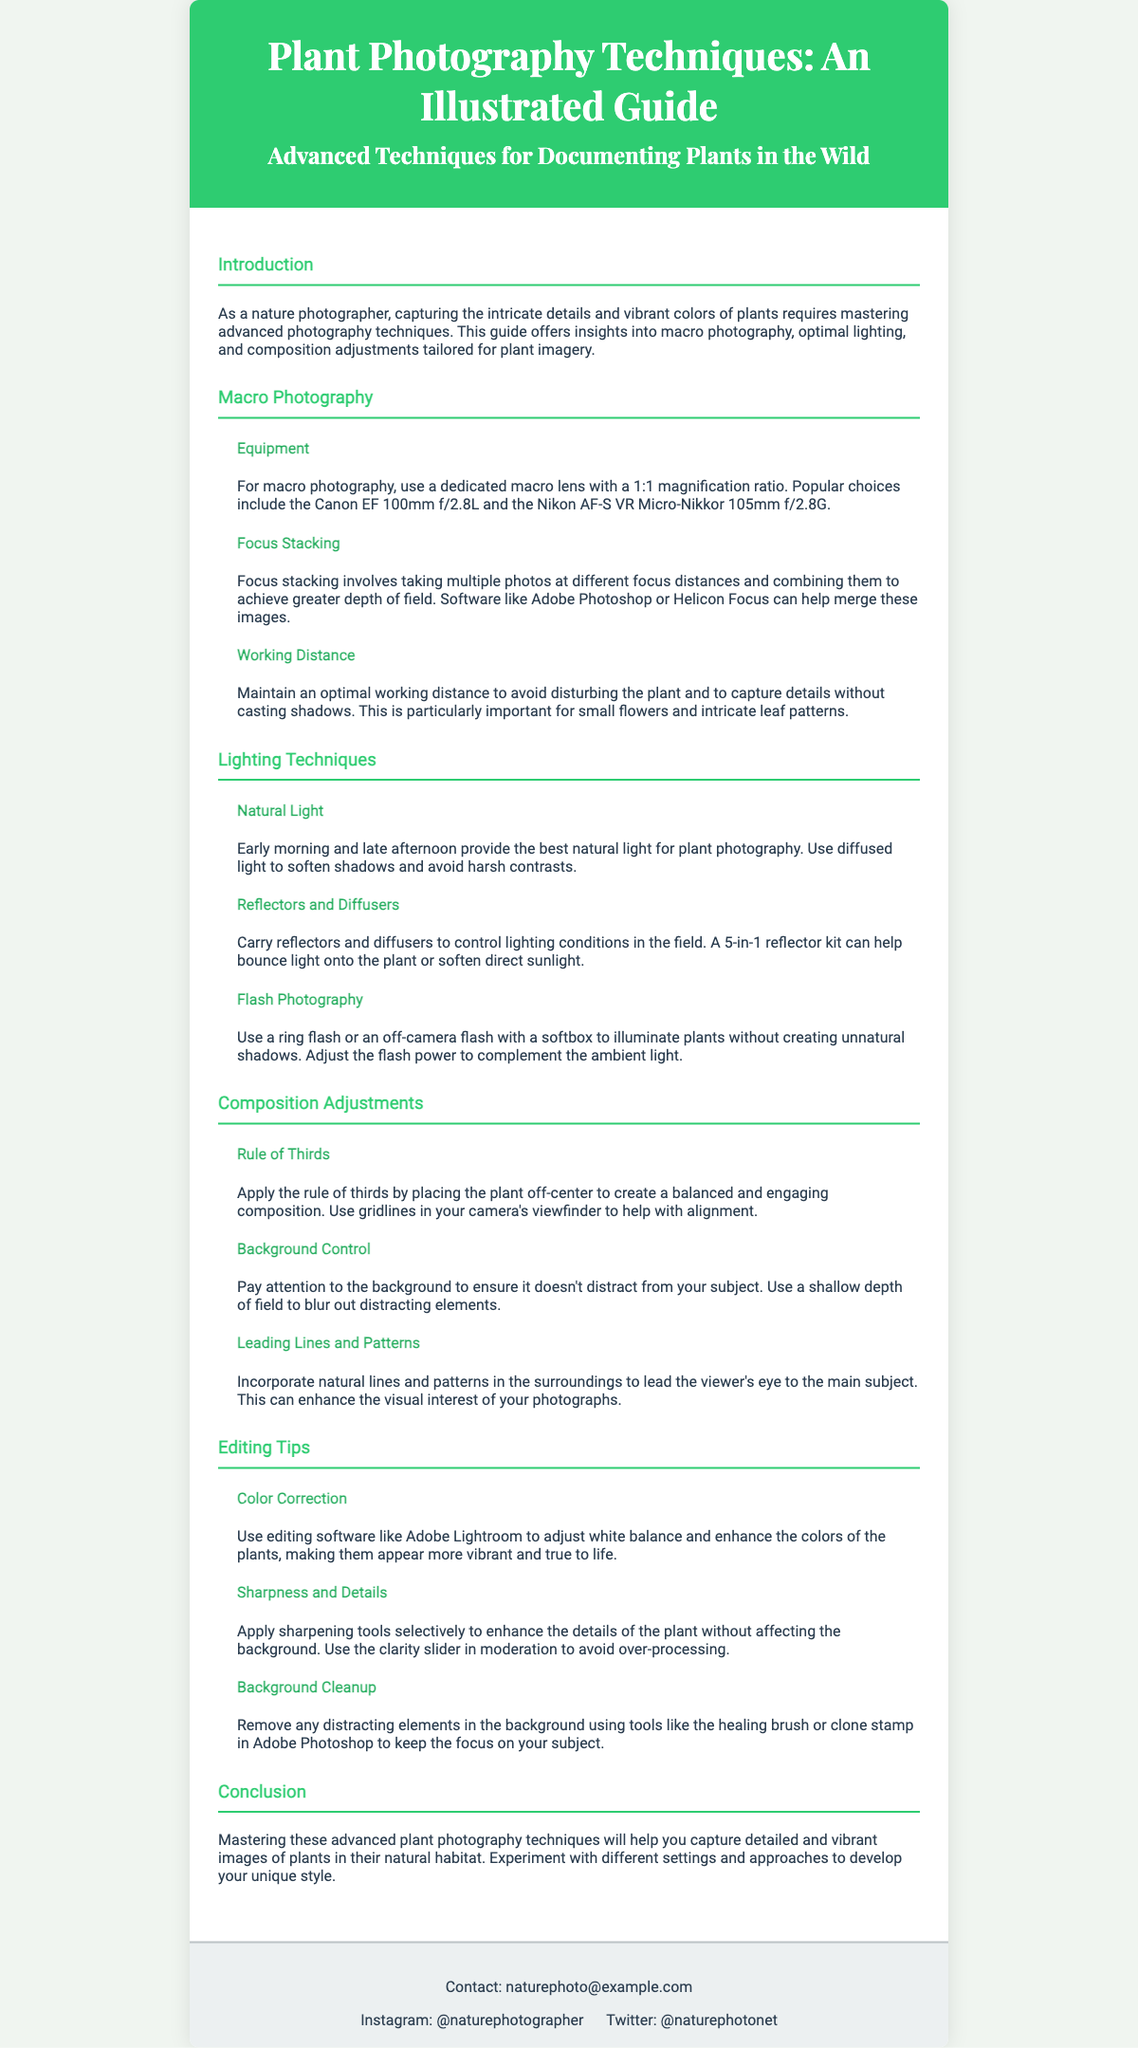What is the title of the document? The title is presented prominently at the top of the Playbill, indicating the subject of the guide.
Answer: Plant Photography Techniques: An Illustrated Guide What is the main focus of the guide? The focus is outlined in the subtitle, summarizing the content of the document.
Answer: Advanced Techniques for Documenting Plants in the Wild What is a recommended macro lens for plant photography? The document lists specific equipment ideal for macro photography.
Answer: Canon EF 100mm f/2.8L What lighting time is suggested for natural light photography? The document provides specific times that are optimal for capturing plant images.
Answer: Early morning and late afternoon What composition rule is highlighted for plant photography? The document suggests a specific artistic principle to enhance the framing of images.
Answer: Rule of Thirds Which software is recommended for color correction? The document advises on editing tools suitable for enhancing plant colors.
Answer: Adobe Lightroom What technique is recommended for enhancing details in macro images? The document describes a method for achieving greater depth of field in photography.
Answer: Focus stacking What should be used to control lighting in the field? The document suggests specific accessories photographers can carry to manipulate lighting conditions.
Answer: Reflectors and diffusers What is mentioned as a common tool for removing background distractions? The document lists a specific tool within editing software that can be used for cleaning up images.
Answer: Healing brush 